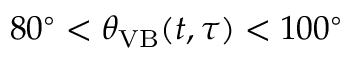<formula> <loc_0><loc_0><loc_500><loc_500>8 0 ^ { \circ } < \theta _ { V B } ( t , \tau ) < 1 0 0 ^ { \circ }</formula> 